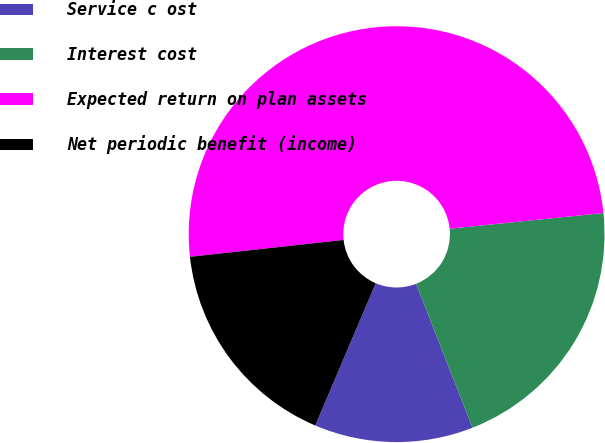<chart> <loc_0><loc_0><loc_500><loc_500><pie_chart><fcel>Service c ost<fcel>Interest cost<fcel>Expected return on plan assets<fcel>Net periodic benefit (income)<nl><fcel>12.35%<fcel>20.67%<fcel>50.12%<fcel>16.86%<nl></chart> 